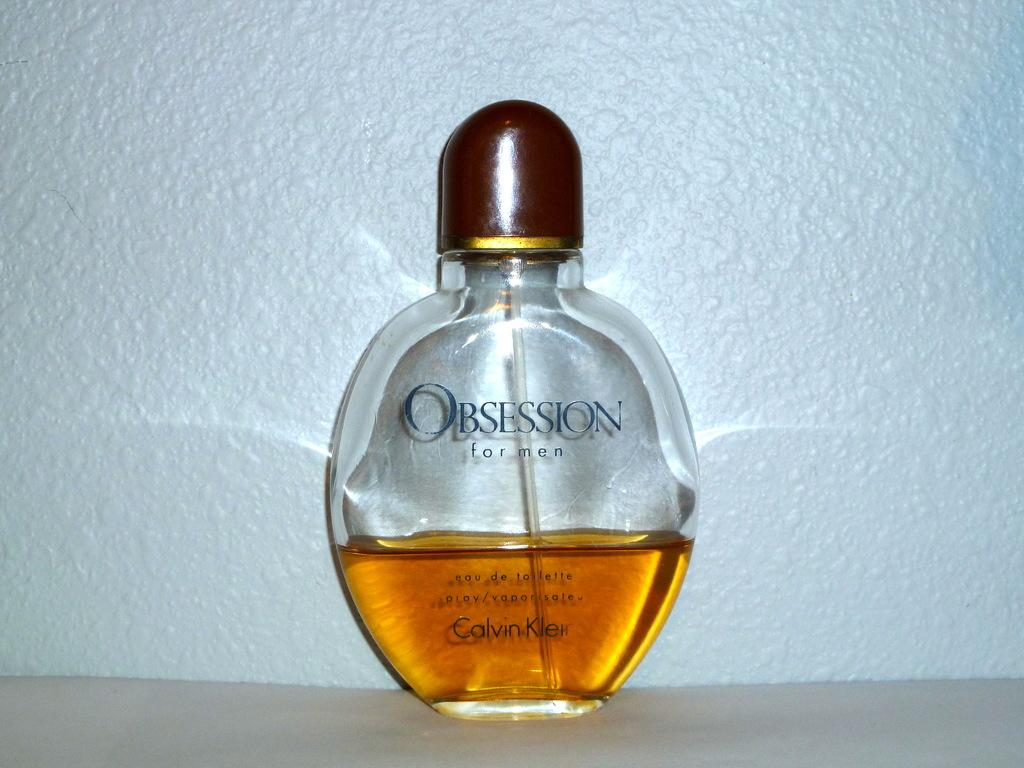Provide a one-sentence caption for the provided image. Calvin Klein makes Obsession eau de toilette for men. 